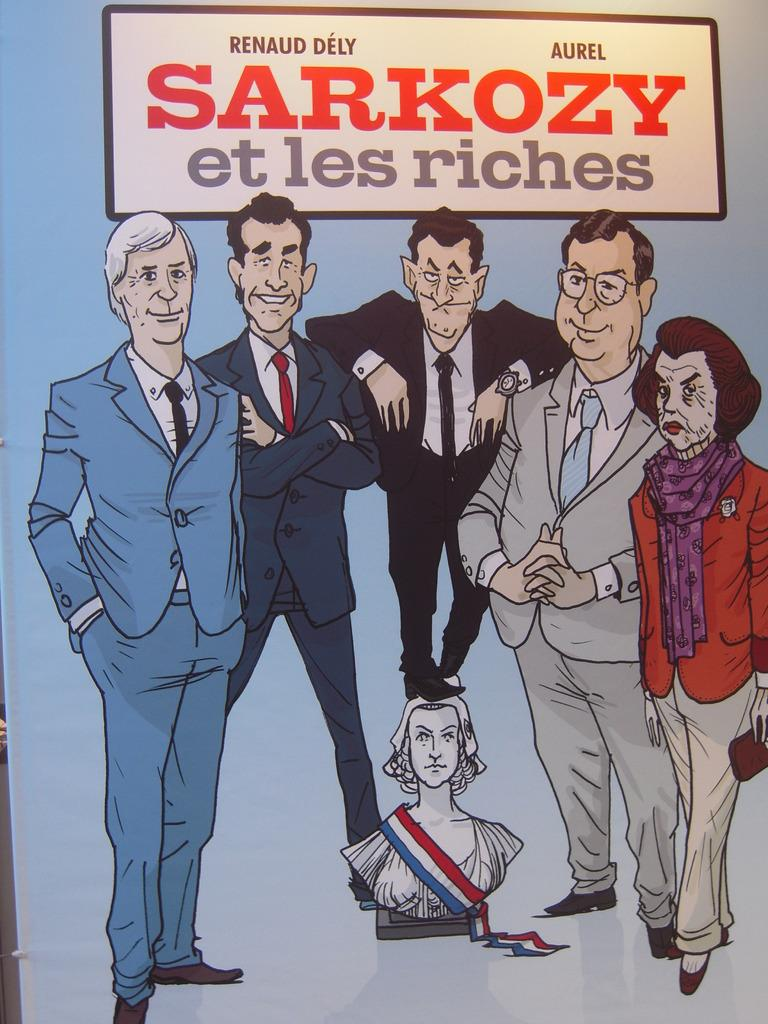What is depicted on the poster in the image? The poster contains animated people. Is there anything else on the poster besides the people? Yes, there is a boat above the people on the poster. What other object can be seen in the image besides the poster? There is a statue in the image. What type of lunch is being served in the image? There is no lunch present in the image; it features a poster with animated people and a statue. Can you tell me what color the chalk is in the image? There is no chalk present in the image. 